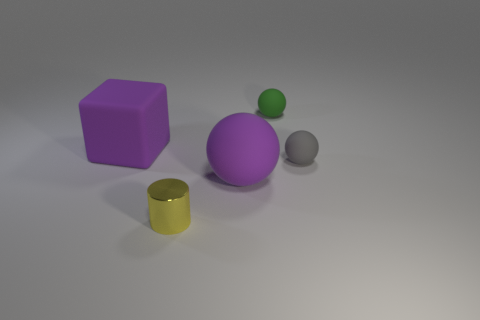There is a object that is both behind the small gray ball and on the right side of the purple cube; what is its shape?
Your answer should be compact. Sphere. How many tiny things are cubes or balls?
Make the answer very short. 2. Is the number of tiny yellow cylinders behind the big cube the same as the number of tiny yellow objects that are on the right side of the green ball?
Ensure brevity in your answer.  Yes. What number of other things are there of the same color as the cube?
Provide a short and direct response. 1. Are there the same number of green balls that are behind the tiny green matte ball and objects?
Provide a succinct answer. No. Do the purple rubber block and the gray ball have the same size?
Your answer should be compact. No. What is the material of the tiny object that is in front of the large purple cube and behind the tiny yellow cylinder?
Provide a short and direct response. Rubber. How many other shiny objects are the same shape as the tiny metallic thing?
Keep it short and to the point. 0. What is the material of the large thing that is in front of the gray rubber object?
Your answer should be very brief. Rubber. Is the number of green balls in front of the cube less than the number of matte blocks?
Offer a terse response. Yes. 